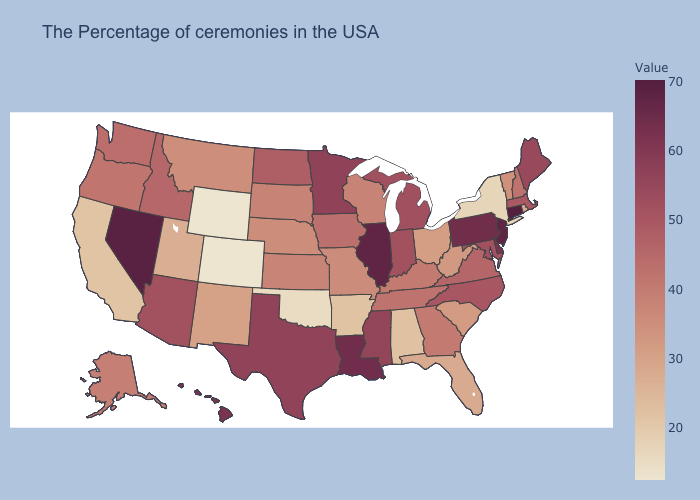Which states have the lowest value in the USA?
Concise answer only. Wyoming, Colorado. Which states have the lowest value in the USA?
Give a very brief answer. Wyoming, Colorado. Among the states that border New York , does Pennsylvania have the lowest value?
Answer briefly. No. Which states hav the highest value in the Northeast?
Give a very brief answer. Connecticut. Among the states that border Massachusetts , does Vermont have the highest value?
Give a very brief answer. No. Is the legend a continuous bar?
Answer briefly. Yes. Which states have the lowest value in the West?
Quick response, please. Wyoming, Colorado. Which states have the highest value in the USA?
Keep it brief. Connecticut. 